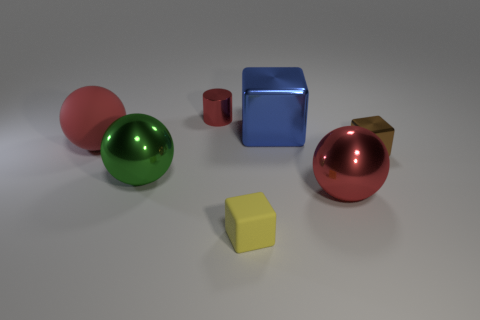Add 1 big brown rubber things. How many objects exist? 8 Subtract all brown metal blocks. How many blocks are left? 2 Subtract all green balls. How many balls are left? 2 Subtract 2 spheres. How many spheres are left? 1 Subtract all purple cubes. How many red balls are left? 2 Subtract all balls. How many objects are left? 4 Subtract all large metal objects. Subtract all red metallic cylinders. How many objects are left? 3 Add 3 big shiny cubes. How many big shiny cubes are left? 4 Add 4 tiny red metallic things. How many tiny red metallic things exist? 5 Subtract 0 purple blocks. How many objects are left? 7 